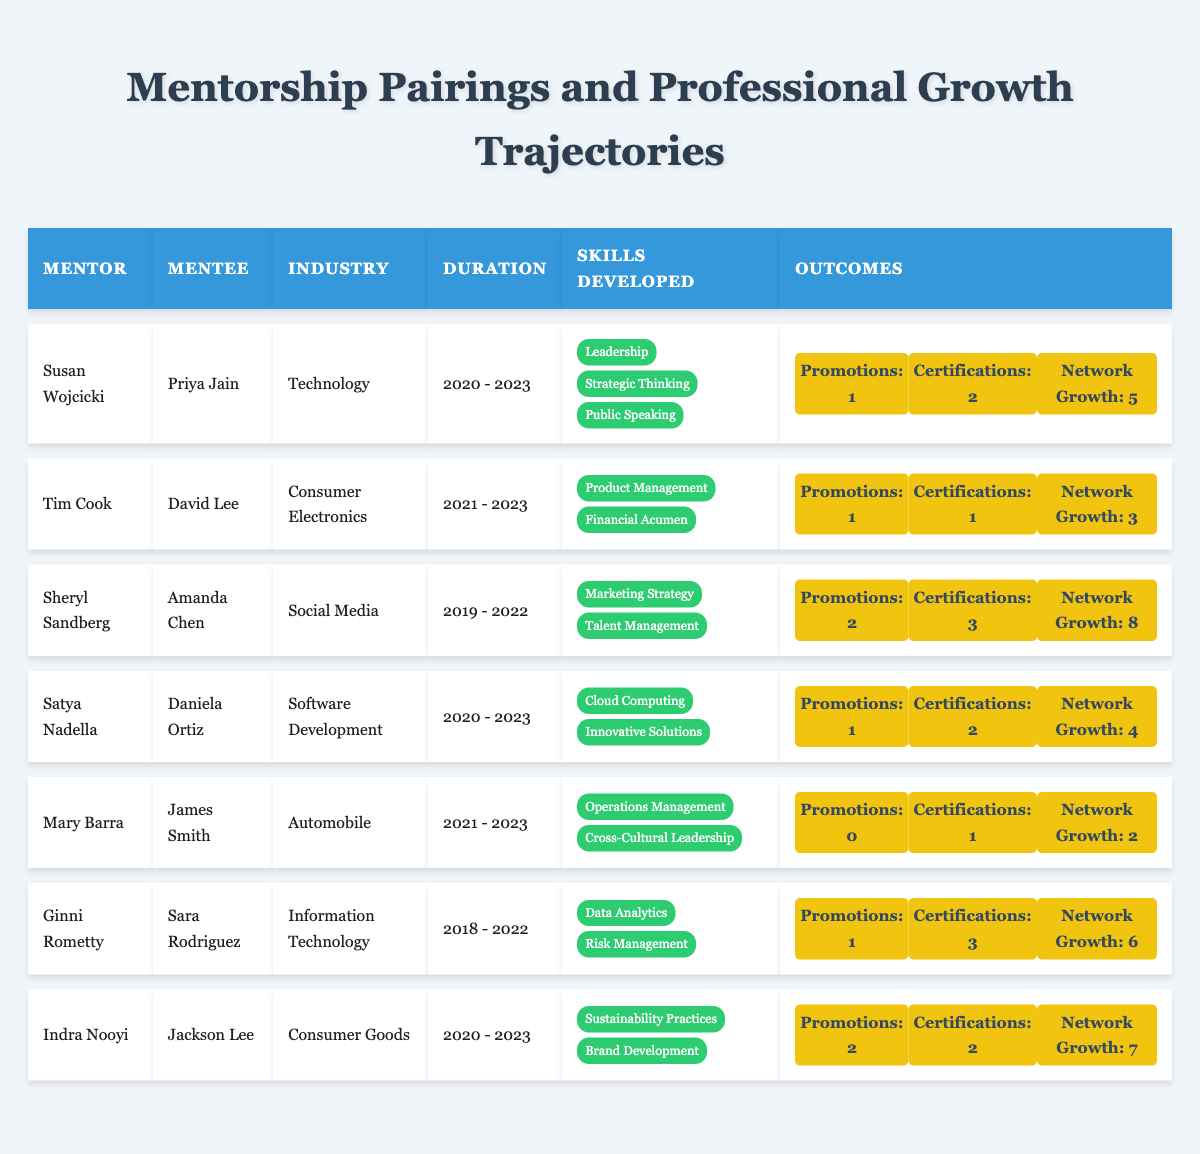What is the total number of promotions achieved by all mentees combined? To find the total promotions, add up the promotions for each mentee: 1 + 1 + 2 + 1 + 0 + 1 + 2 = 8.
Answer: 8 Which mentor had the highest number of skill certifications awarded to their mentee? Looking at the skill certifications, Sheryl Sandberg and Ginni Rometty both awarded 3 certifications each. Therefore, the highest number is 3.
Answer: 3 Did any mentee without a promotion also achieve a skill certification? Mary Barra's mentee, James Smith, had 0 promotions but did achieve 1 certification. Thus, the answer is yes.
Answer: Yes Who had the longest mentorship duration and what was it? The longest mentorship duration in the table is held by Sheryl Sandberg and Amanda Chen, from 2019 to 2022, which is 3 years.
Answer: 3 years What is the average network growth achieved by mentees from the Consumer Goods industry? The mentee from the Consumer Goods industry was Jackson Lee, who had a network growth of 7. Since there is only 1 data point in this category, the average is 7.
Answer: 7 Which mentorship pairing resulted in the most extensive network expansion? Amanda Chen’s pairing with Sheryl Sandberg resulted in a network expansion of 8, which is the highest.
Answer: 8 Was there any mentor whose mentee did not achieve any promotions? Yes, Mary Barra's mentee, James Smith, did not achieve any promotions.
Answer: Yes Which mentor contributed to the development of skills in both Cloud Computing and Innovative Solutions? Satya Nadella was the mentor who worked on these skills with mentee Daniela Ortiz.
Answer: Satya Nadella How many mentors had a mentee that received at least two skill certifications? The mentors who had mentees with at least two skill certifications are Susan Wojcicki, Sheryl Sandberg, Ginni Rometty, and Indra Nooyi, totaling 4 mentors.
Answer: 4 What was the outcome for all mentees who were mentored by Tim Cook? Tim Cook's mentee, David Lee, achieved 1 promotion, 1 certification, and 3network expansions.
Answer: 1 promotion, 1 certification, 3 network expansions Which mentee had the highest network growth, and what was the value? Amanda Chen had the highest network growth of 8 from her mentorship with Sheryl Sandberg.
Answer: 8 